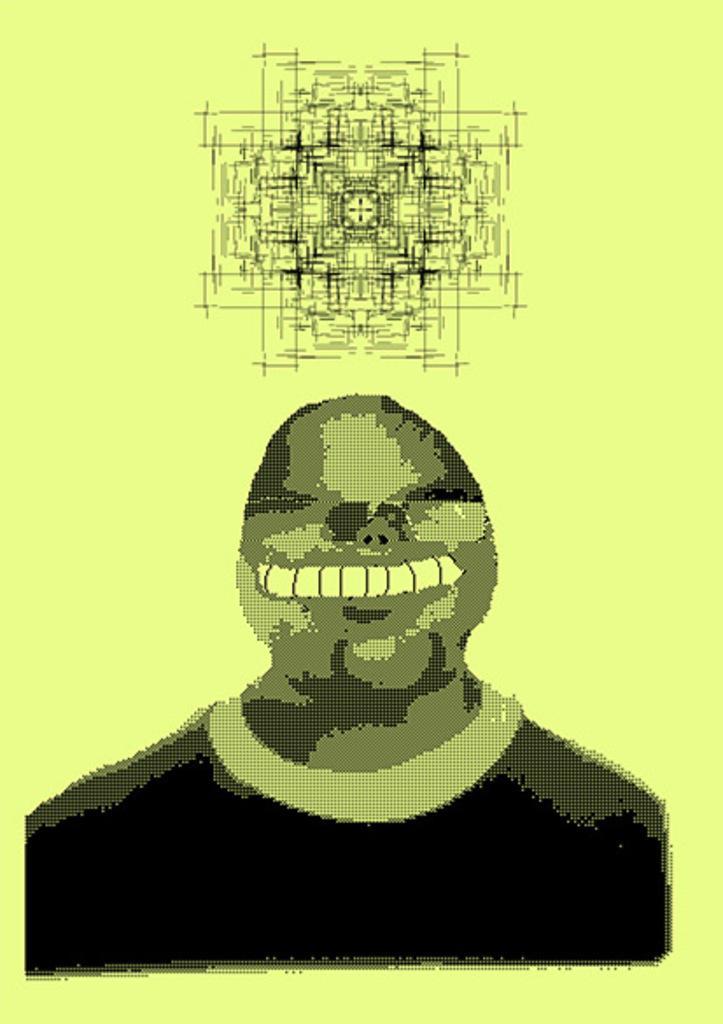Can you describe this image briefly? In this image, we can see a person illustration and sketch. 